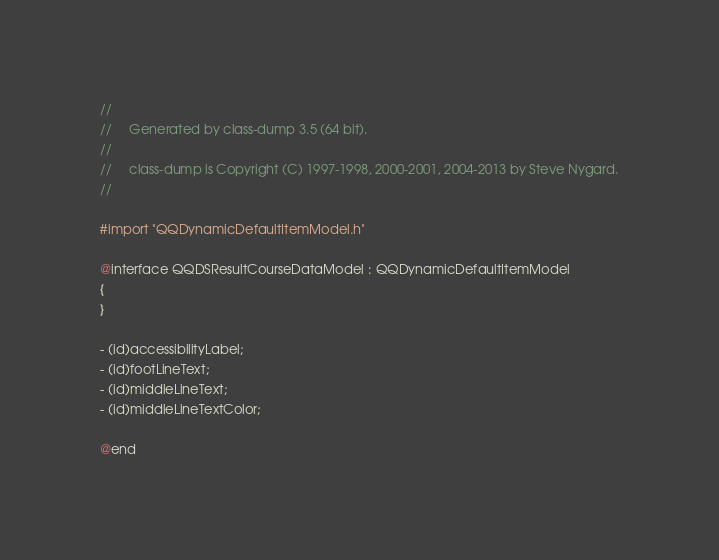<code> <loc_0><loc_0><loc_500><loc_500><_C_>//
//     Generated by class-dump 3.5 (64 bit).
//
//     class-dump is Copyright (C) 1997-1998, 2000-2001, 2004-2013 by Steve Nygard.
//

#import "QQDynamicDefaultItemModel.h"

@interface QQDSResultCourseDataModel : QQDynamicDefaultItemModel
{
}

- (id)accessibilityLabel;
- (id)footLineText;
- (id)middleLineText;
- (id)middleLineTextColor;

@end

</code> 